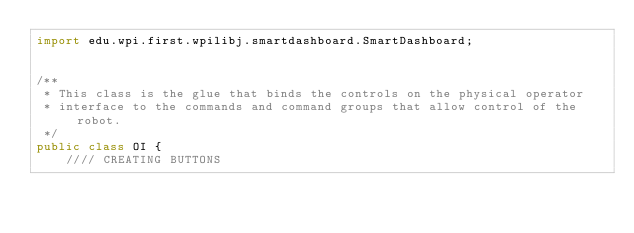Convert code to text. <code><loc_0><loc_0><loc_500><loc_500><_Java_>import edu.wpi.first.wpilibj.smartdashboard.SmartDashboard;


/**
 * This class is the glue that binds the controls on the physical operator
 * interface to the commands and command groups that allow control of the robot.
 */
public class OI {
    //// CREATING BUTTONS</code> 